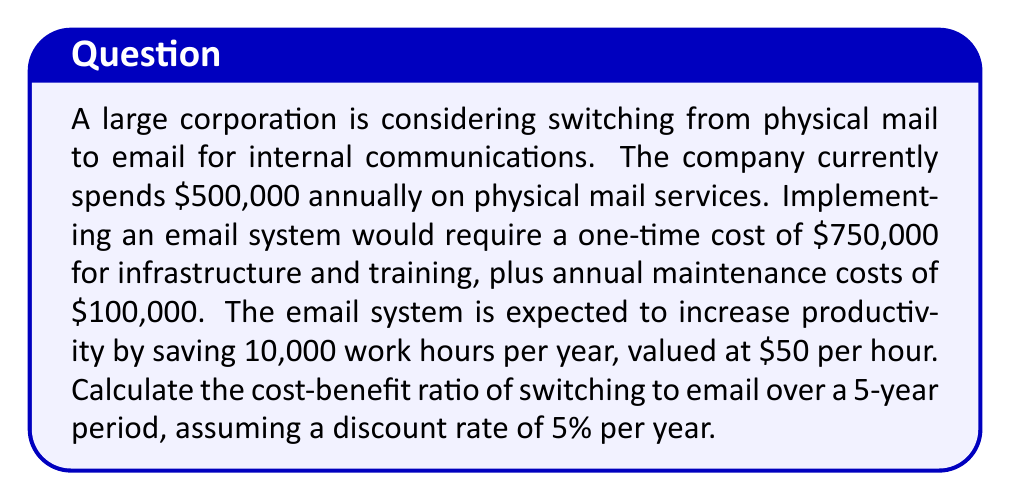Could you help me with this problem? To solve this problem, we need to calculate the present value of costs and benefits over the 5-year period, then determine the cost-benefit ratio.

1. Calculate the present value of costs:
   a. One-time implementation cost: $750,000
   b. Annual maintenance cost: $100,000 per year for 5 years
   c. Present value of maintenance costs:
      $$PV_{maintenance} = 100,000 \cdot \sum_{t=1}^{5} \frac{1}{(1+0.05)^t}$$
      $$PV_{maintenance} = 100,000 \cdot 4.3295 = 432,950$$
   d. Total present value of costs: $750,000 + $432,950 = $1,182,950

2. Calculate the present value of benefits:
   a. Annual savings from eliminating physical mail: $500,000
   b. Annual productivity gains: 10,000 hours × $50/hour = $500,000
   c. Total annual benefit: $1,000,000
   d. Present value of benefits over 5 years:
      $$PV_{benefits} = 1,000,000 \cdot \sum_{t=1}^{5} \frac{1}{(1+0.05)^t}$$
      $$PV_{benefits} = 1,000,000 \cdot 4.3295 = 4,329,500$$

3. Calculate the cost-benefit ratio:
   $$\text{Cost-Benefit Ratio} = \frac{PV_{benefits}}{PV_{costs}}$$
   $$\text{Cost-Benefit Ratio} = \frac{4,329,500}{1,182,950}$$
Answer: The cost-benefit ratio is approximately 3.66, indicating that the benefits outweigh the costs by a factor of 3.66 over the 5-year period. 